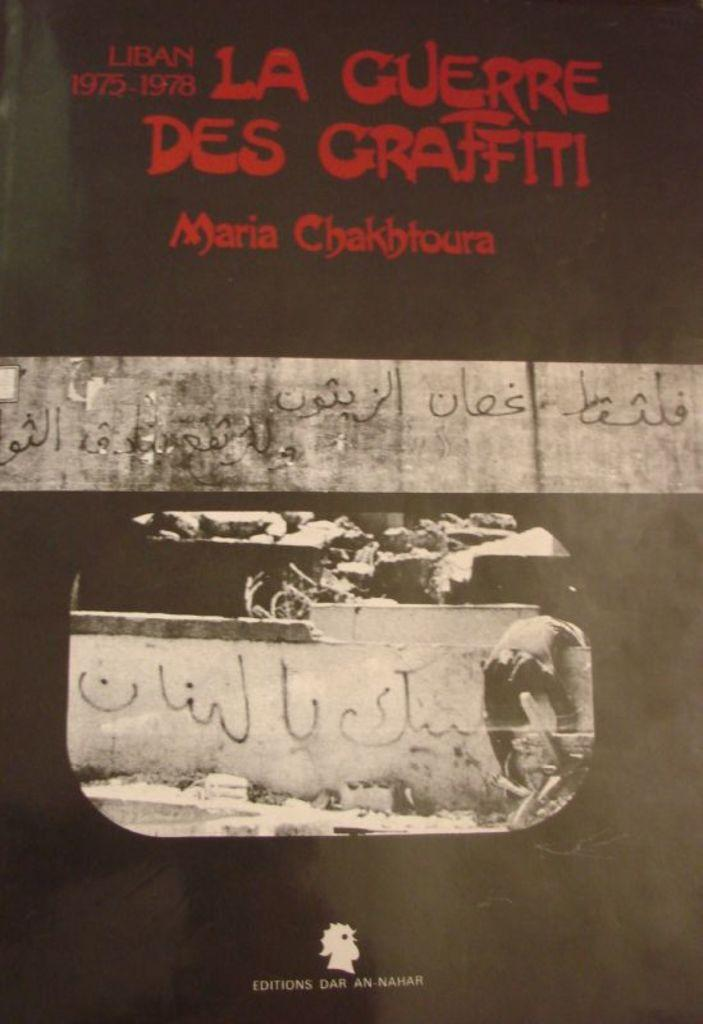<image>
Create a compact narrative representing the image presented. A book cover that is written by Maria Chakbloura. 